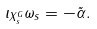Convert formula to latex. <formula><loc_0><loc_0><loc_500><loc_500>\iota _ { X _ { s } ^ { G } } \omega _ { s } = - \tilde { \alpha } .</formula> 